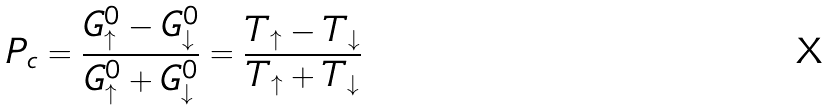Convert formula to latex. <formula><loc_0><loc_0><loc_500><loc_500>P _ { c } = \frac { G _ { \uparrow } ^ { 0 } - G _ { \downarrow } ^ { 0 } } { G _ { \uparrow } ^ { 0 } + G _ { \downarrow } ^ { 0 } } = \frac { T _ { \uparrow } - T _ { \downarrow } } { T _ { \uparrow } + T _ { \downarrow } }</formula> 